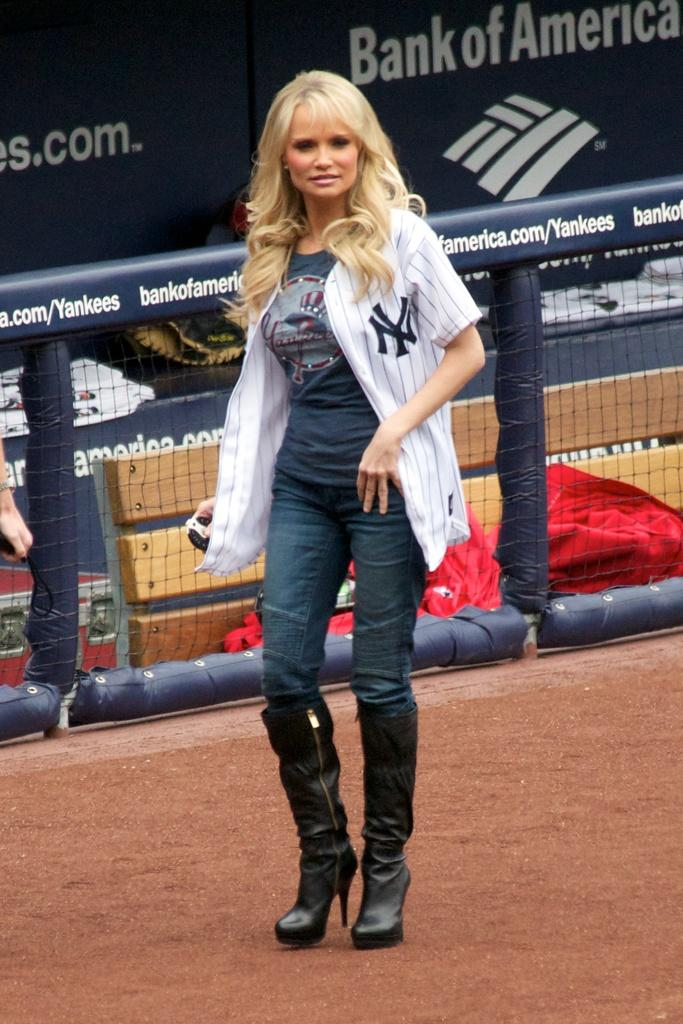<image>
Write a terse but informative summary of the picture. a lady walking with the letters NY on her shirt 